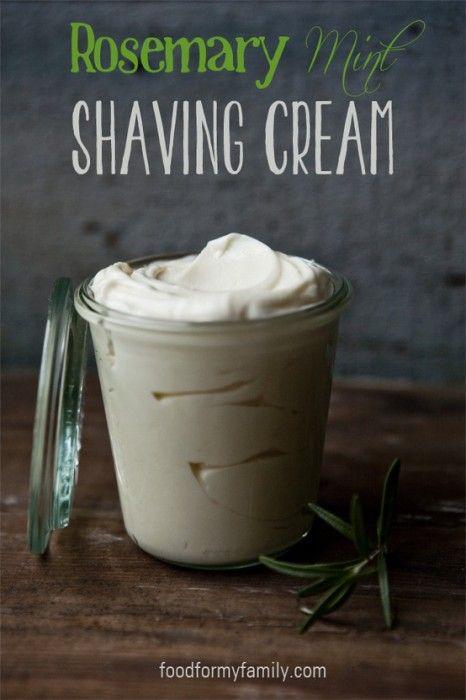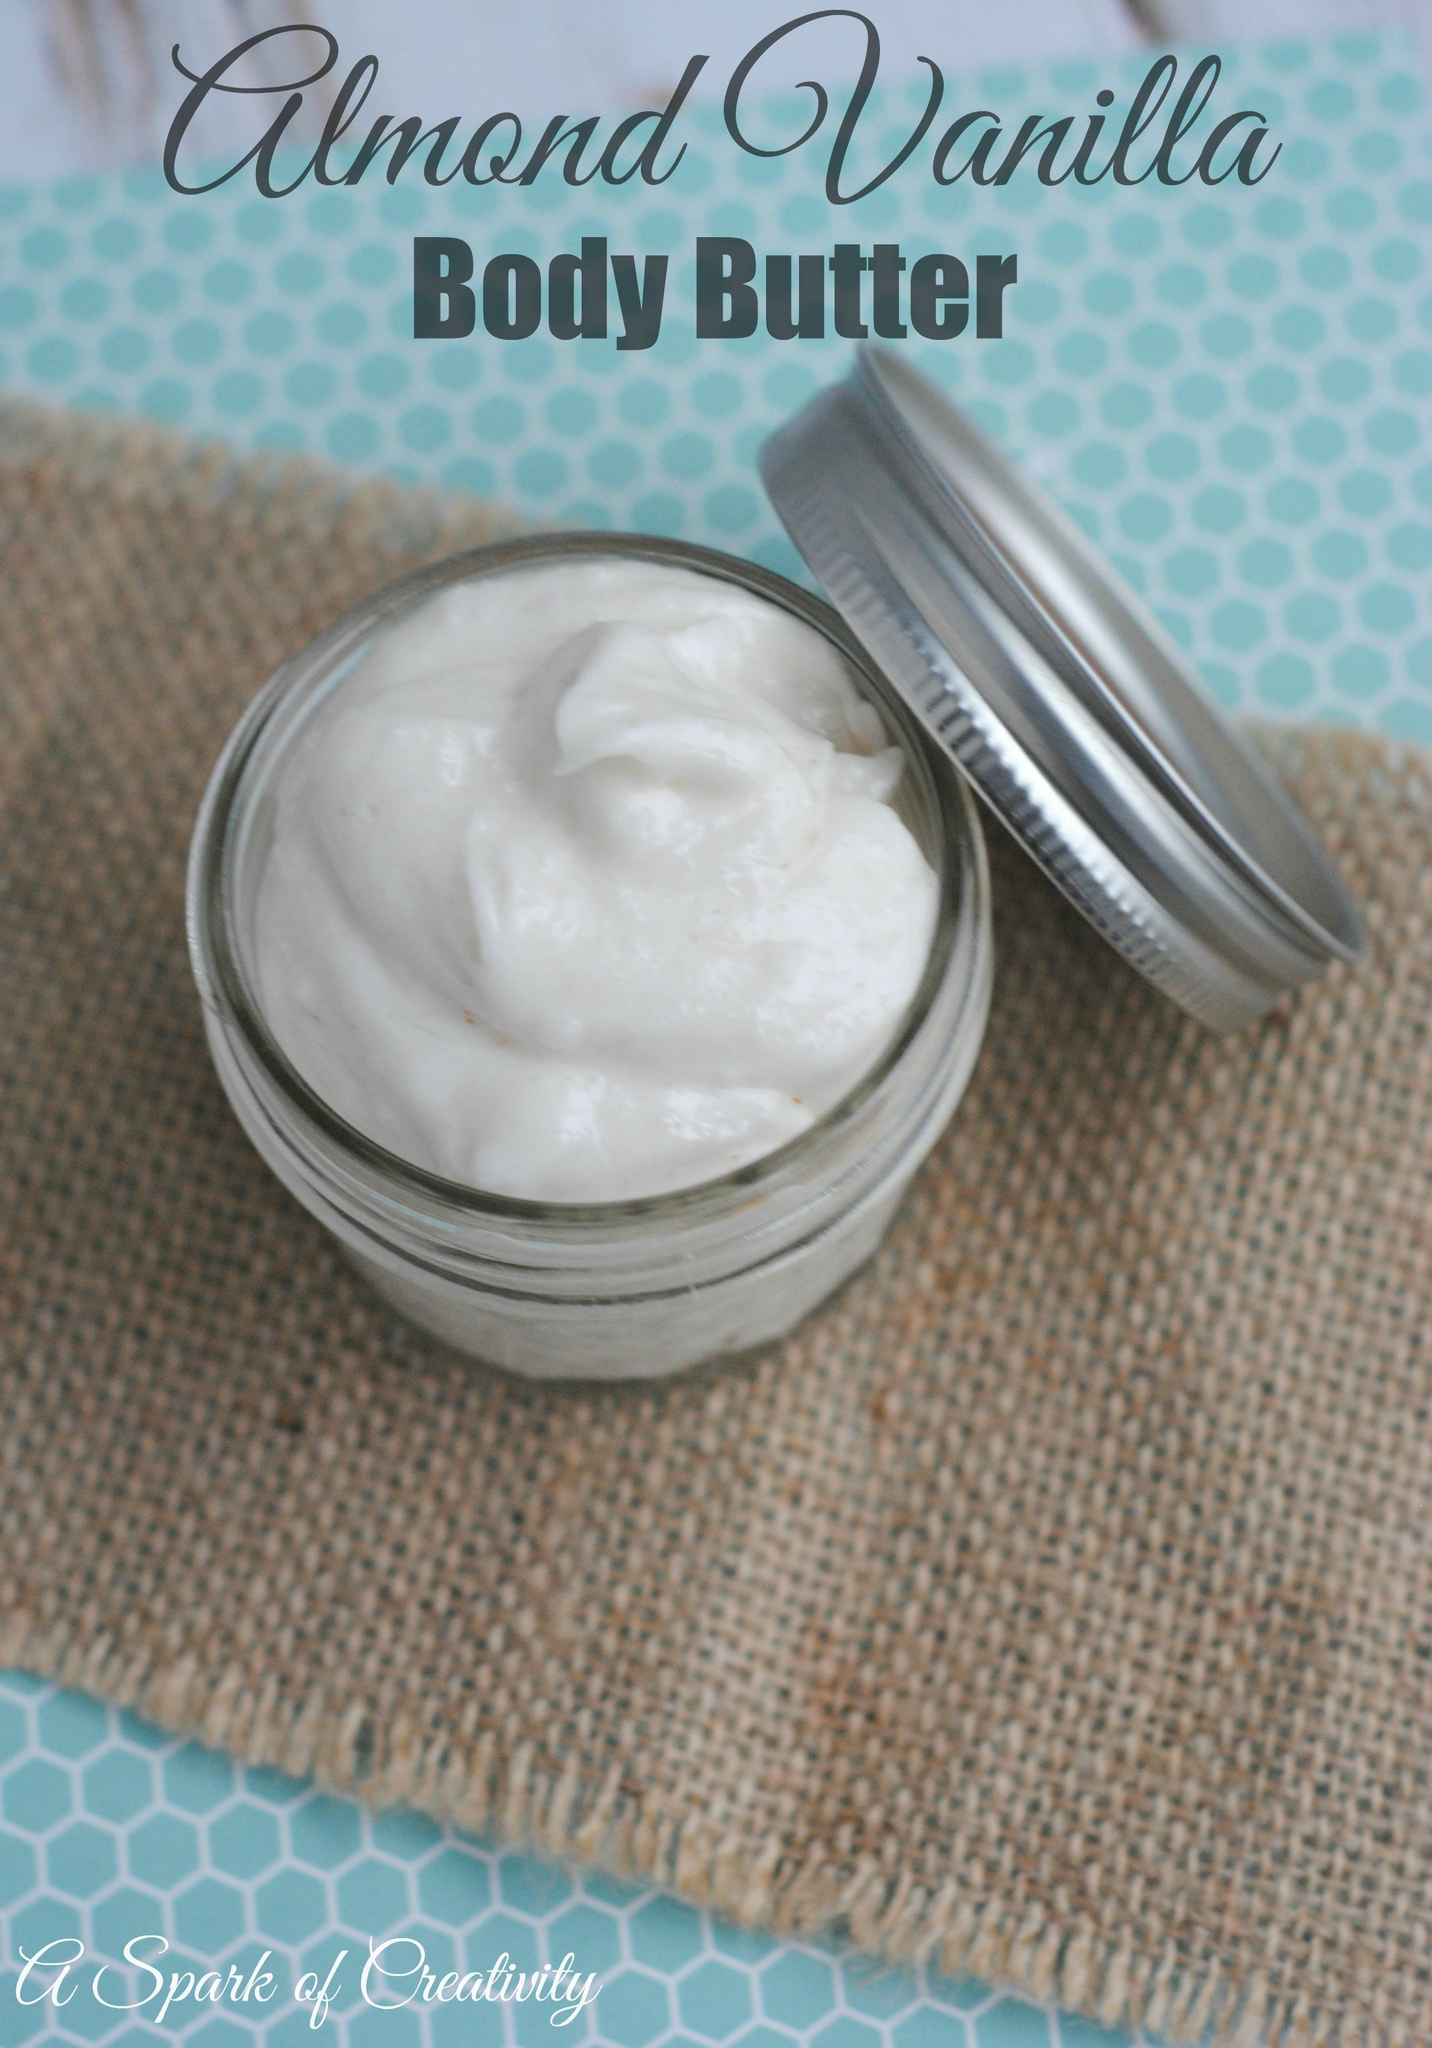The first image is the image on the left, the second image is the image on the right. Examine the images to the left and right. Is the description "A silver lid is resting against a container in the image on the right." accurate? Answer yes or no. Yes. The first image is the image on the left, the second image is the image on the right. Analyze the images presented: Is the assertion "Each image shows one open jar filled with a creamy substance, and in one image, a silver lid is leaning at any angle against the edge of the jar." valid? Answer yes or no. Yes. 